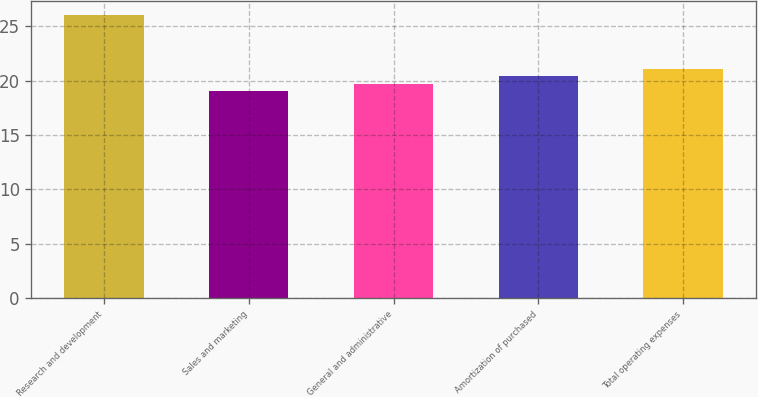Convert chart. <chart><loc_0><loc_0><loc_500><loc_500><bar_chart><fcel>Research and development<fcel>Sales and marketing<fcel>General and administrative<fcel>Amortization of purchased<fcel>Total operating expenses<nl><fcel>26<fcel>19<fcel>19.7<fcel>20.4<fcel>21.1<nl></chart> 